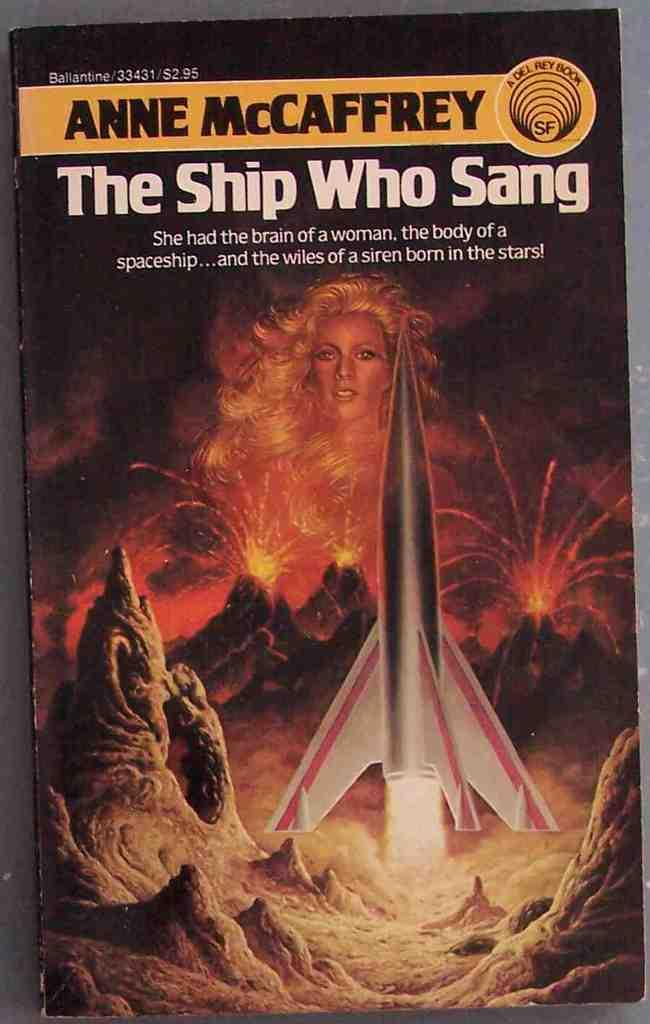<image>
Give a short and clear explanation of the subsequent image. A book from the author Anne McCaffrey is displayed. 